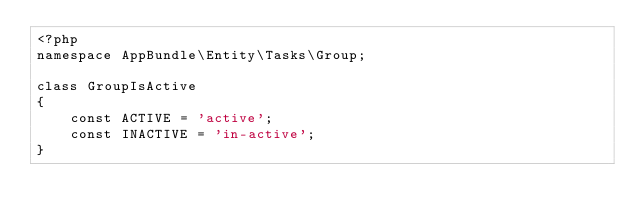Convert code to text. <code><loc_0><loc_0><loc_500><loc_500><_PHP_><?php
namespace AppBundle\Entity\Tasks\Group;

class GroupIsActive
{
    const ACTIVE = 'active';
    const INACTIVE = 'in-active';
}</code> 